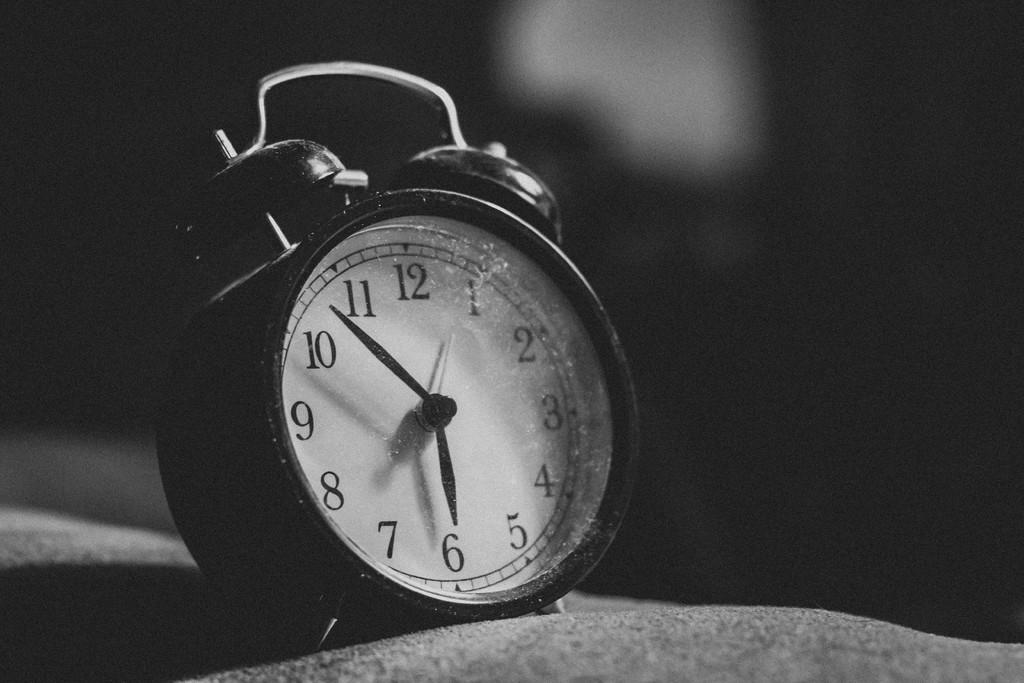<image>
Describe the image concisely. a clock with the number 6 on it 